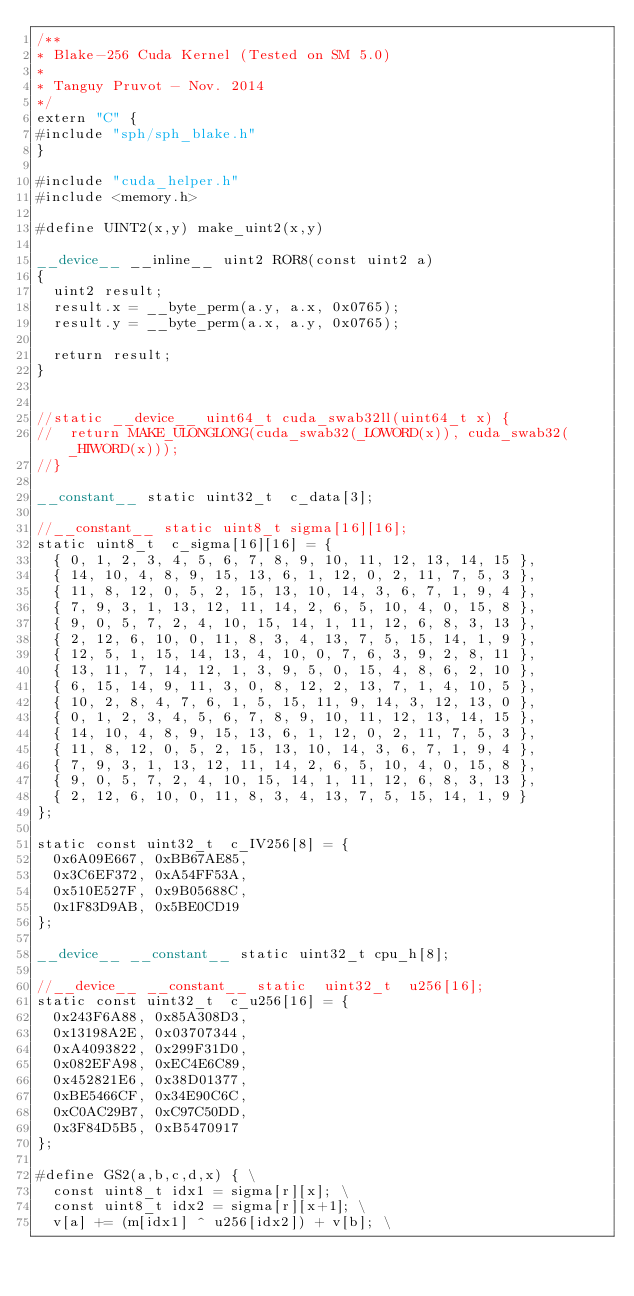<code> <loc_0><loc_0><loc_500><loc_500><_Cuda_>/**
* Blake-256 Cuda Kernel (Tested on SM 5.0)
*
* Tanguy Pruvot - Nov. 2014
*/
extern "C" {
#include "sph/sph_blake.h"
}

#include "cuda_helper.h"
#include <memory.h>

#define UINT2(x,y) make_uint2(x,y)

__device__ __inline__ uint2 ROR8(const uint2 a)
{
	uint2 result;
	result.x = __byte_perm(a.y, a.x, 0x0765);
	result.y = __byte_perm(a.x, a.y, 0x0765);

	return result;
}


//static __device__ uint64_t cuda_swab32ll(uint64_t x) {
//	return MAKE_ULONGLONG(cuda_swab32(_LOWORD(x)), cuda_swab32(_HIWORD(x)));
//}

__constant__ static uint32_t  c_data[3];

//__constant__ static uint8_t sigma[16][16];
static uint8_t  c_sigma[16][16] = {
	{ 0, 1, 2, 3, 4, 5, 6, 7, 8, 9, 10, 11, 12, 13, 14, 15 },
	{ 14, 10, 4, 8, 9, 15, 13, 6, 1, 12, 0, 2, 11, 7, 5, 3 },
	{ 11, 8, 12, 0, 5, 2, 15, 13, 10, 14, 3, 6, 7, 1, 9, 4 },
	{ 7, 9, 3, 1, 13, 12, 11, 14, 2, 6, 5, 10, 4, 0, 15, 8 },
	{ 9, 0, 5, 7, 2, 4, 10, 15, 14, 1, 11, 12, 6, 8, 3, 13 },
	{ 2, 12, 6, 10, 0, 11, 8, 3, 4, 13, 7, 5, 15, 14, 1, 9 },
	{ 12, 5, 1, 15, 14, 13, 4, 10, 0, 7, 6, 3, 9, 2, 8, 11 },
	{ 13, 11, 7, 14, 12, 1, 3, 9, 5, 0, 15, 4, 8, 6, 2, 10 },
	{ 6, 15, 14, 9, 11, 3, 0, 8, 12, 2, 13, 7, 1, 4, 10, 5 },
	{ 10, 2, 8, 4, 7, 6, 1, 5, 15, 11, 9, 14, 3, 12, 13, 0 },
	{ 0, 1, 2, 3, 4, 5, 6, 7, 8, 9, 10, 11, 12, 13, 14, 15 },
	{ 14, 10, 4, 8, 9, 15, 13, 6, 1, 12, 0, 2, 11, 7, 5, 3 },
	{ 11, 8, 12, 0, 5, 2, 15, 13, 10, 14, 3, 6, 7, 1, 9, 4 },
	{ 7, 9, 3, 1, 13, 12, 11, 14, 2, 6, 5, 10, 4, 0, 15, 8 },
	{ 9, 0, 5, 7, 2, 4, 10, 15, 14, 1, 11, 12, 6, 8, 3, 13 },
	{ 2, 12, 6, 10, 0, 11, 8, 3, 4, 13, 7, 5, 15, 14, 1, 9 }
};

static const uint32_t  c_IV256[8] = {
	0x6A09E667, 0xBB67AE85,
	0x3C6EF372, 0xA54FF53A,
	0x510E527F, 0x9B05688C,
	0x1F83D9AB, 0x5BE0CD19
};

__device__ __constant__ static uint32_t cpu_h[8];

//__device__ __constant__ static  uint32_t  u256[16];
static const uint32_t  c_u256[16] = {
	0x243F6A88, 0x85A308D3,
	0x13198A2E, 0x03707344,
	0xA4093822, 0x299F31D0,
	0x082EFA98, 0xEC4E6C89,
	0x452821E6, 0x38D01377,
	0xBE5466CF, 0x34E90C6C,
	0xC0AC29B7, 0xC97C50DD,
	0x3F84D5B5, 0xB5470917
};

#define GS2(a,b,c,d,x) { \
	const uint8_t idx1 = sigma[r][x]; \
	const uint8_t idx2 = sigma[r][x+1]; \
	v[a] += (m[idx1] ^ u256[idx2]) + v[b]; \</code> 